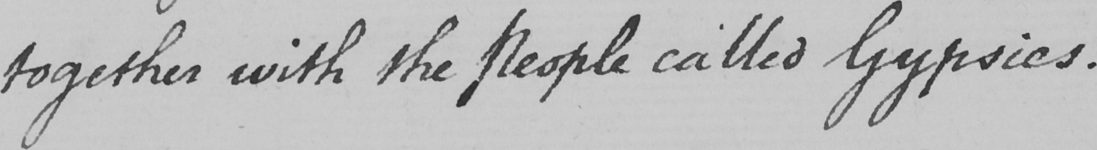What is written in this line of handwriting? together with the People called Gypsies . 